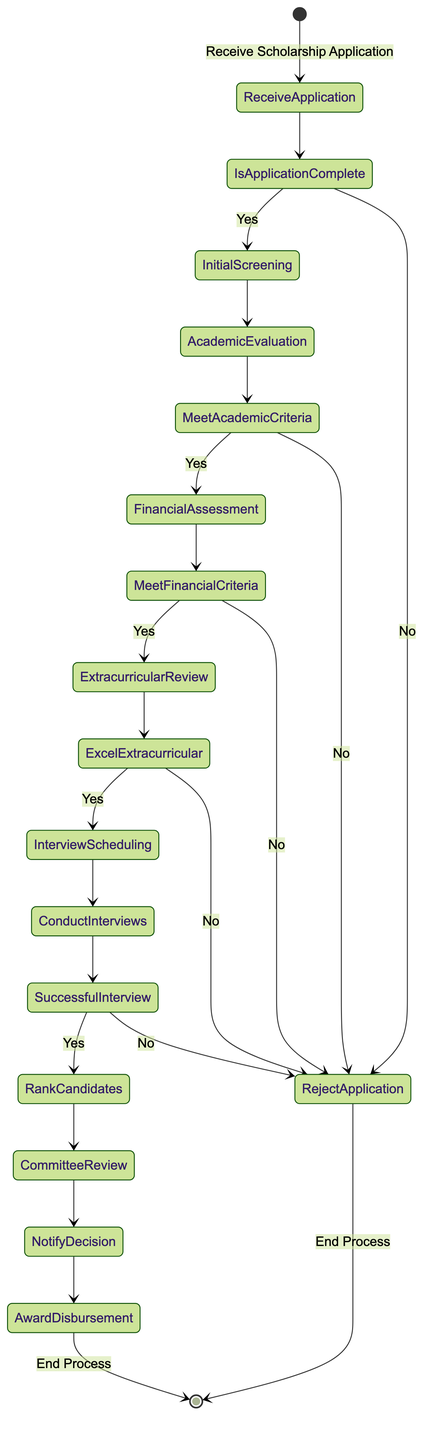What is the first action in the diagram? The diagram starts with the action "Receive Scholarship Application," which is the first step in the workflow.
Answer: Receive Scholarship Application How many decision points are present in the diagram? The diagram contains five decision points: Is Application Complete?, Does the Candidate Meet Academic Criteria?, Does the Candidate Meet Financial Criteria?, Does the Candidate Excel in Extracurricular Activities?, and Is Candidate Successful in Interview?.
Answer: Five What follows the "Initial Application Screening" action? After the "Initial Application Screening," the workflow proceeds to the decision point "Is Application Complete?" where the application is evaluated for completeness.
Answer: Is Application Complete? If a candidate does not excel in extracurricular activities, what is the outcome? If a candidate does not excel in extracurricular activities, the workflow leads to "Reject Application," which effectively ends the process for that candidate.
Answer: Reject Application Which action immediately precedes the "Committee Review" step? The step that immediately precedes the "Committee Review" is "Rank Candidates," where candidates are ranked based on their overall evaluation before they are reviewed by the scholarship committee.
Answer: Rank Candidates If the candidate is successful in the interview, what is the next action taken? If the candidate is successful in the interview, the next action taken is "Rank Candidates," which involves ranking all candidates based on the previous evaluations.
Answer: Rank Candidates What is the endpoint of the workflow? The endpoint of the workflow is defined as the "End Process," which indicates that all actions and decisions have been completed, marking the conclusion of the scholarship awarding process.
Answer: End Process What happens if the candidate does not meet financial criteria? If the candidate does not meet financial criteria, the workflow directs to "Reject Application," indicating that their application is not considered further for the scholarship.
Answer: Reject Application What action occurs after the Notification of Decision? After the "Notification of Decision," the next action is "Award Disbursement," where the scholarship funds are processed and distributed to the awarded candidates.
Answer: Award Disbursement 